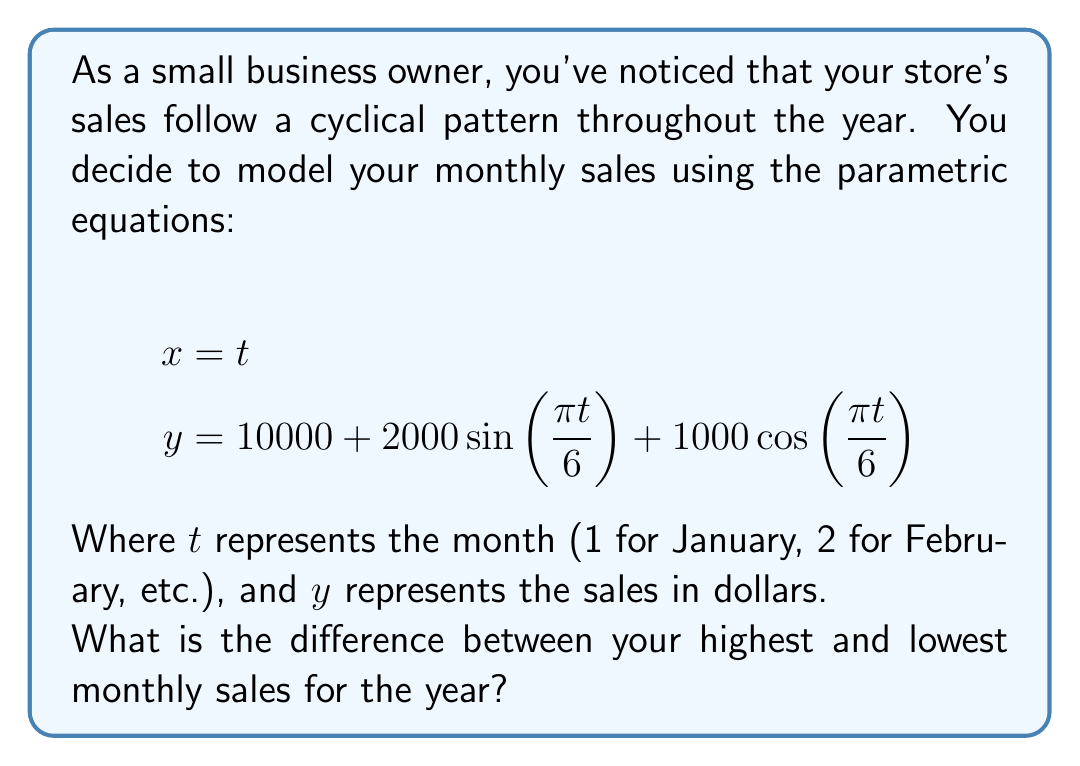Can you answer this question? To find the difference between the highest and lowest monthly sales, we need to follow these steps:

1) First, we need to find the maximum and minimum values of $y$. Since $x = t$ doesn't affect the $y$ value, we can focus solely on the $y$ equation.

2) The $y$ equation is in the form: $y = A + B\sin(\omega t) + C\cos(\omega t)$
   Where $A = 10000$, $B = 2000$, $C = 1000$, and $\omega = \frac{\pi}{6}$

3) For such equations, the maximum and minimum occur at:
   $$y_{max} = A + \sqrt{B^2 + C^2}$$
   $$y_{min} = A - \sqrt{B^2 + C^2}$$

4) Let's calculate $\sqrt{B^2 + C^2}$:
   $$\sqrt{B^2 + C^2} = \sqrt{2000^2 + 1000^2} = \sqrt{4,000,000 + 1,000,000} = \sqrt{5,000,000} = 2236.07$$

5) Now we can calculate $y_{max}$ and $y_{min}$:
   $$y_{max} = 10000 + 2236.07 = 12236.07$$
   $$y_{min} = 10000 - 2236.07 = 7763.93$$

6) The difference between the highest and lowest sales is:
   $$y_{max} - y_{min} = 12236.07 - 7763.93 = 4472.14$$

Therefore, the difference between the highest and lowest monthly sales is approximately $4472.14.
Answer: $4472.14 